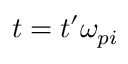Convert formula to latex. <formula><loc_0><loc_0><loc_500><loc_500>t = t ^ { \prime } \omega _ { p i }</formula> 